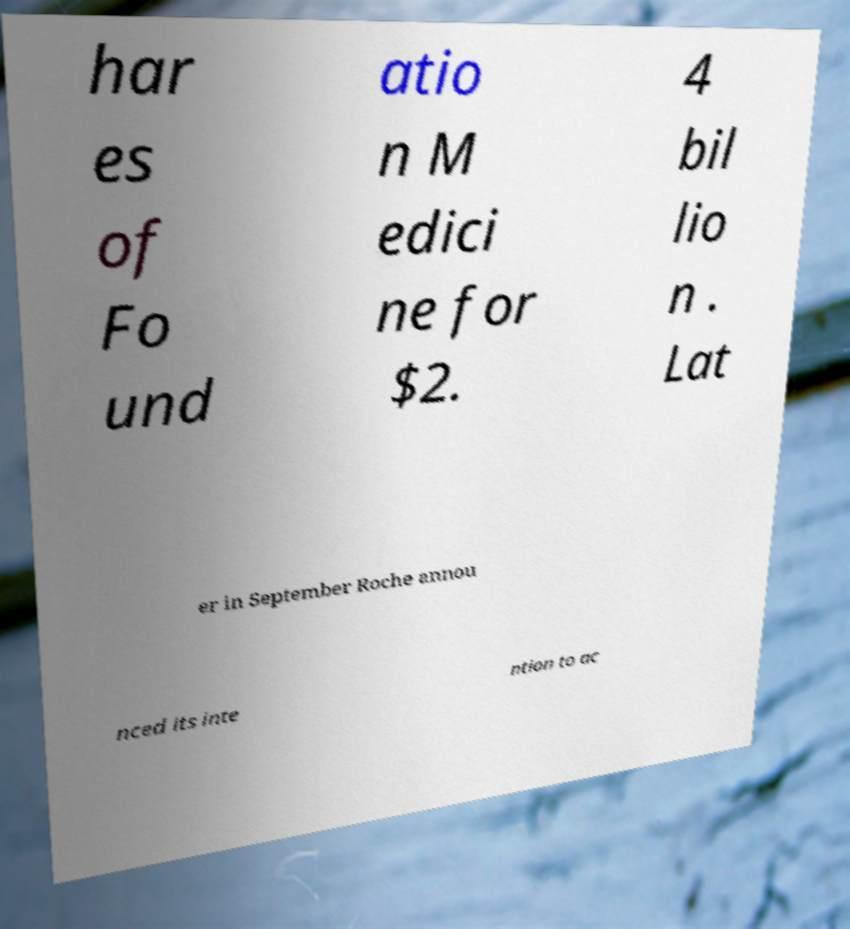There's text embedded in this image that I need extracted. Can you transcribe it verbatim? har es of Fo und atio n M edici ne for $2. 4 bil lio n . Lat er in September Roche annou nced its inte ntion to ac 